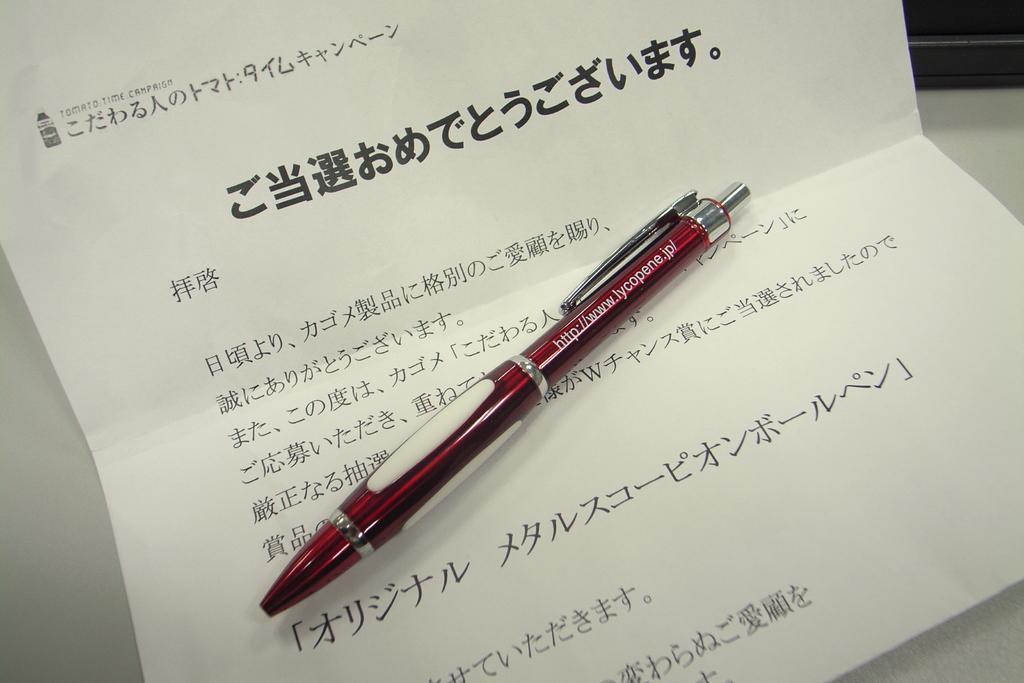Please provide a concise description of this image. In this image I can see a red pen on a white paper, some matter is written on the paper. 